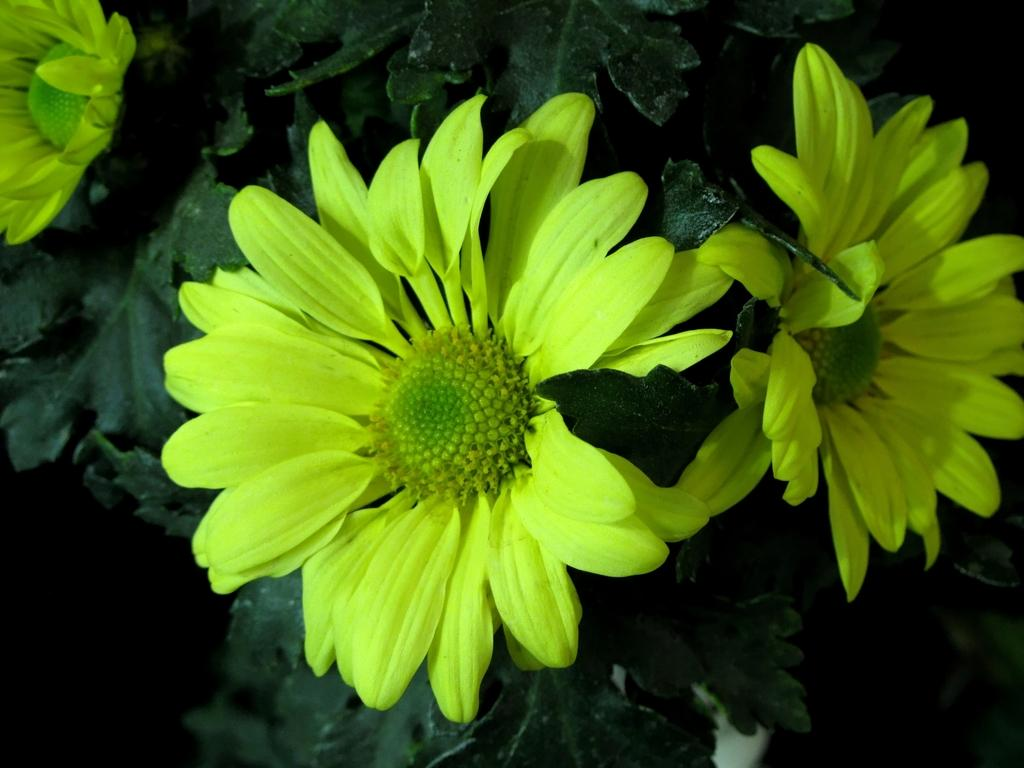What type of plants can be seen in the image? There are flowers in the image. What else can be seen in the background of the image? There are leaves in the background of the image. What type of hall can be seen in the image? There is no hall present in the image; it features flowers and leaves. How does the earth appear in the image? The image does not show the earth as a planet or any geographical features; it focuses on flowers and leaves. 